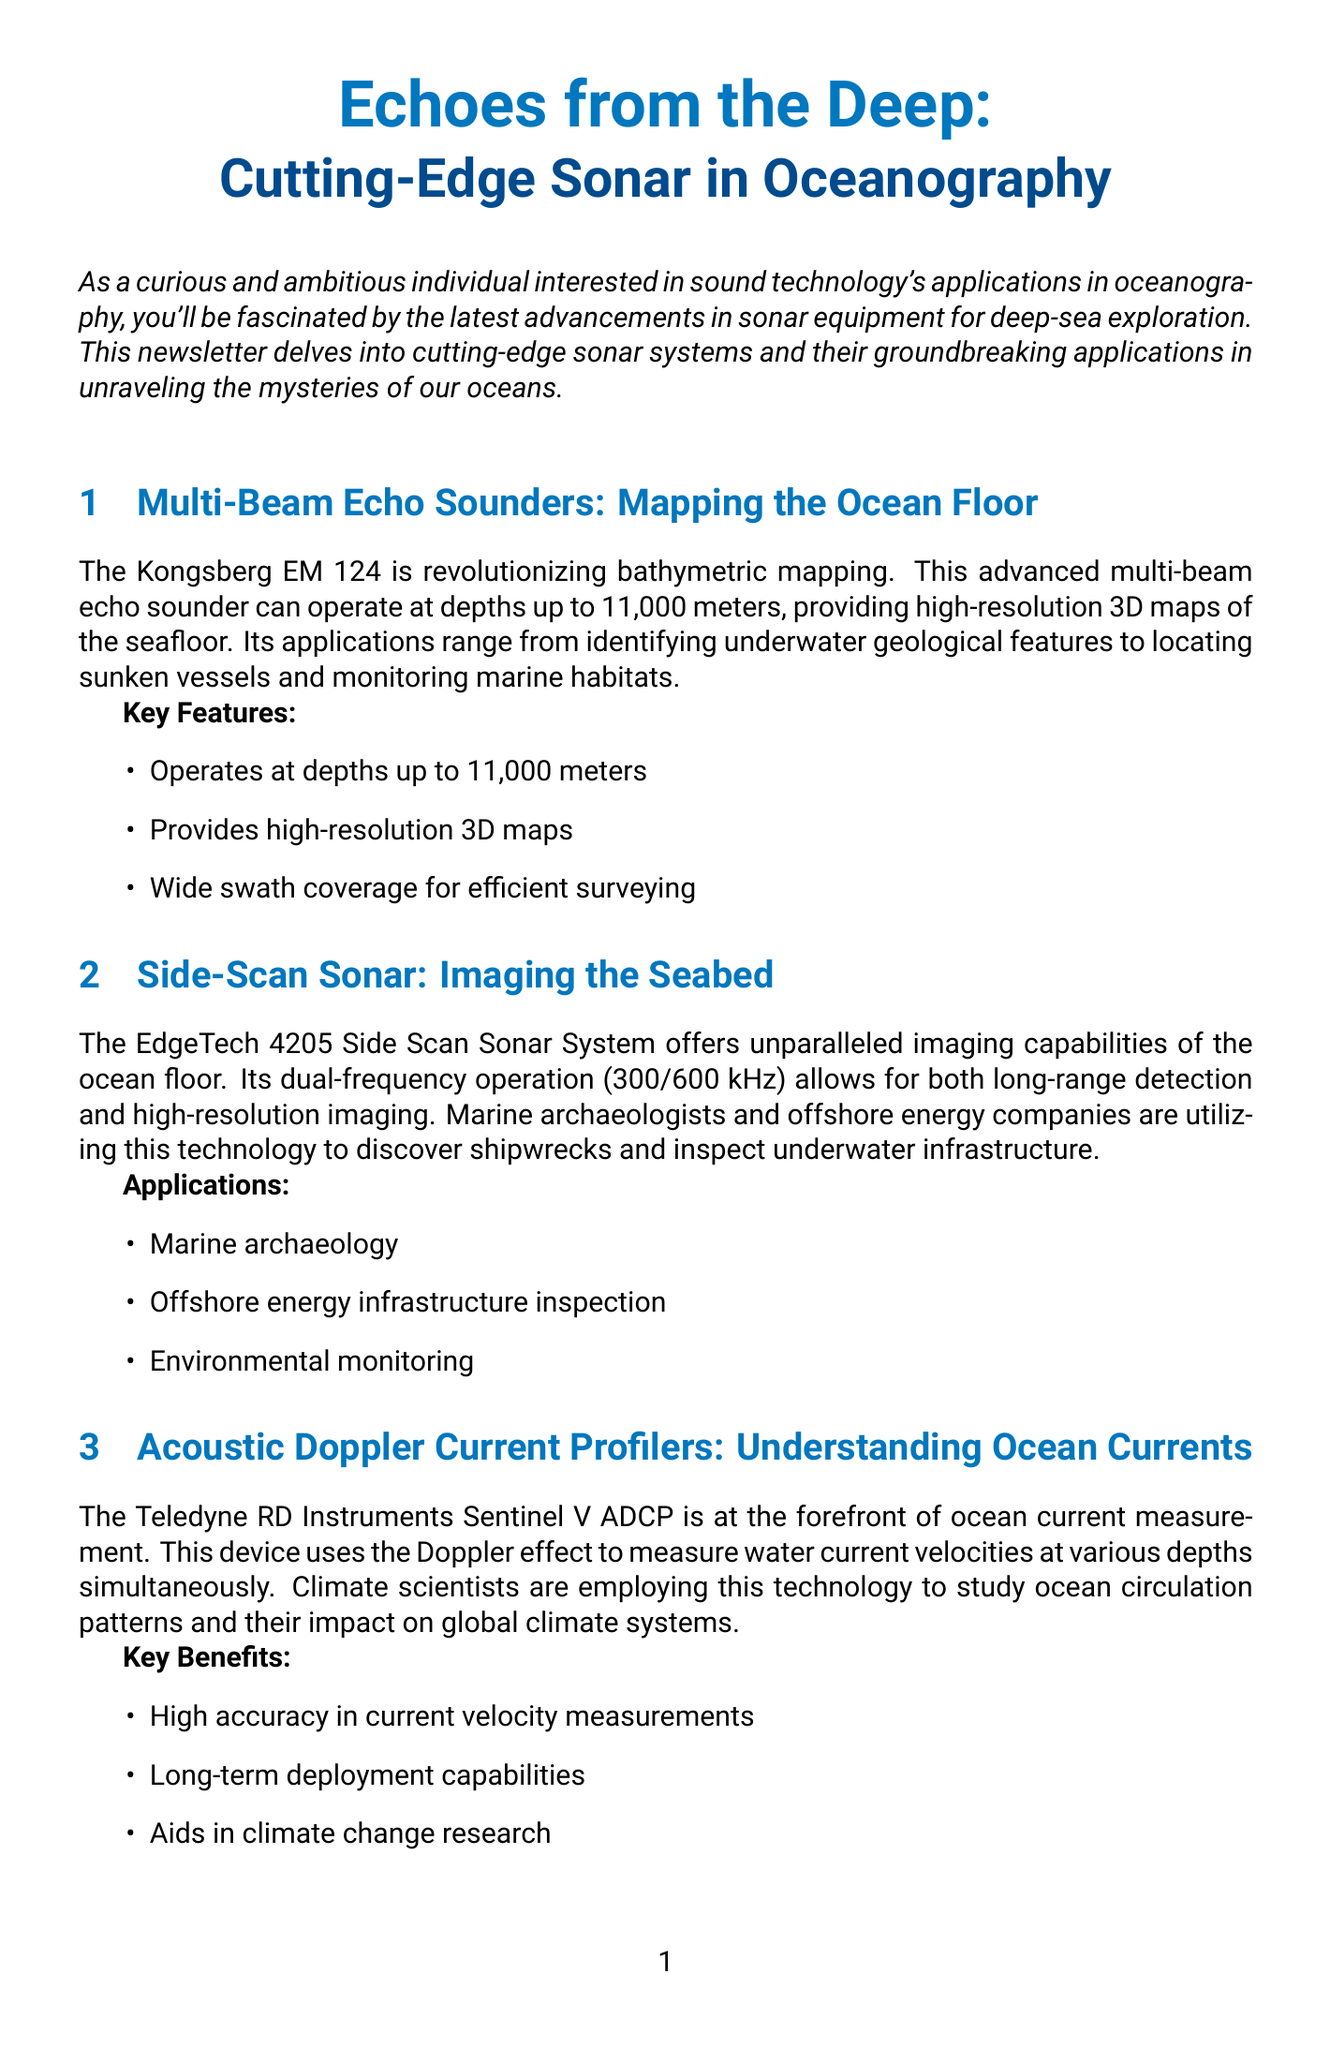What is the title of the newsletter? The title of the newsletter is prominently displayed at the beginning and is "Echoes from the Deep: Cutting-Edge Sonar in Oceanography".
Answer: Echoes from the Deep: Cutting-Edge Sonar in Oceanography What is the depth capability of the Kongsberg EM 124? The Kongsberg EM 124 can operate at depths of up to 11,000 meters, as specified in its description.
Answer: 11,000 meters What are the key features of the EdgeTech 4205 Side Scan Sonar System? The newsletter lists specific applications for the EdgeTech 4205, which include marine archaeology, offshore energy inspection, and environmental monitoring.
Answer: Marine archaeology, Offshore energy infrastructure inspection, Environmental monitoring What technology is the Teledyne RD Instruments Sentinel V ADCP based on? The document states that the device uses the Doppler effect to measure water current velocities, highlighting its measurement mechanism.
Answer: Doppler effect What key findings were made during the deep-sea expedition in the Mariana Trench? The case study section summarizes the discoveries made during the expedition, specifically mentioning new geological formations and deep-sea species.
Answer: Discovery of new geological formations, Identification of several previously unknown deep-sea species What future technology is mentioned for sonar processing? The newsletter discusses the potential of AI-enhanced sonar processing for future developments in sonar technology.
Answer: AI-enhanced sonar processing 